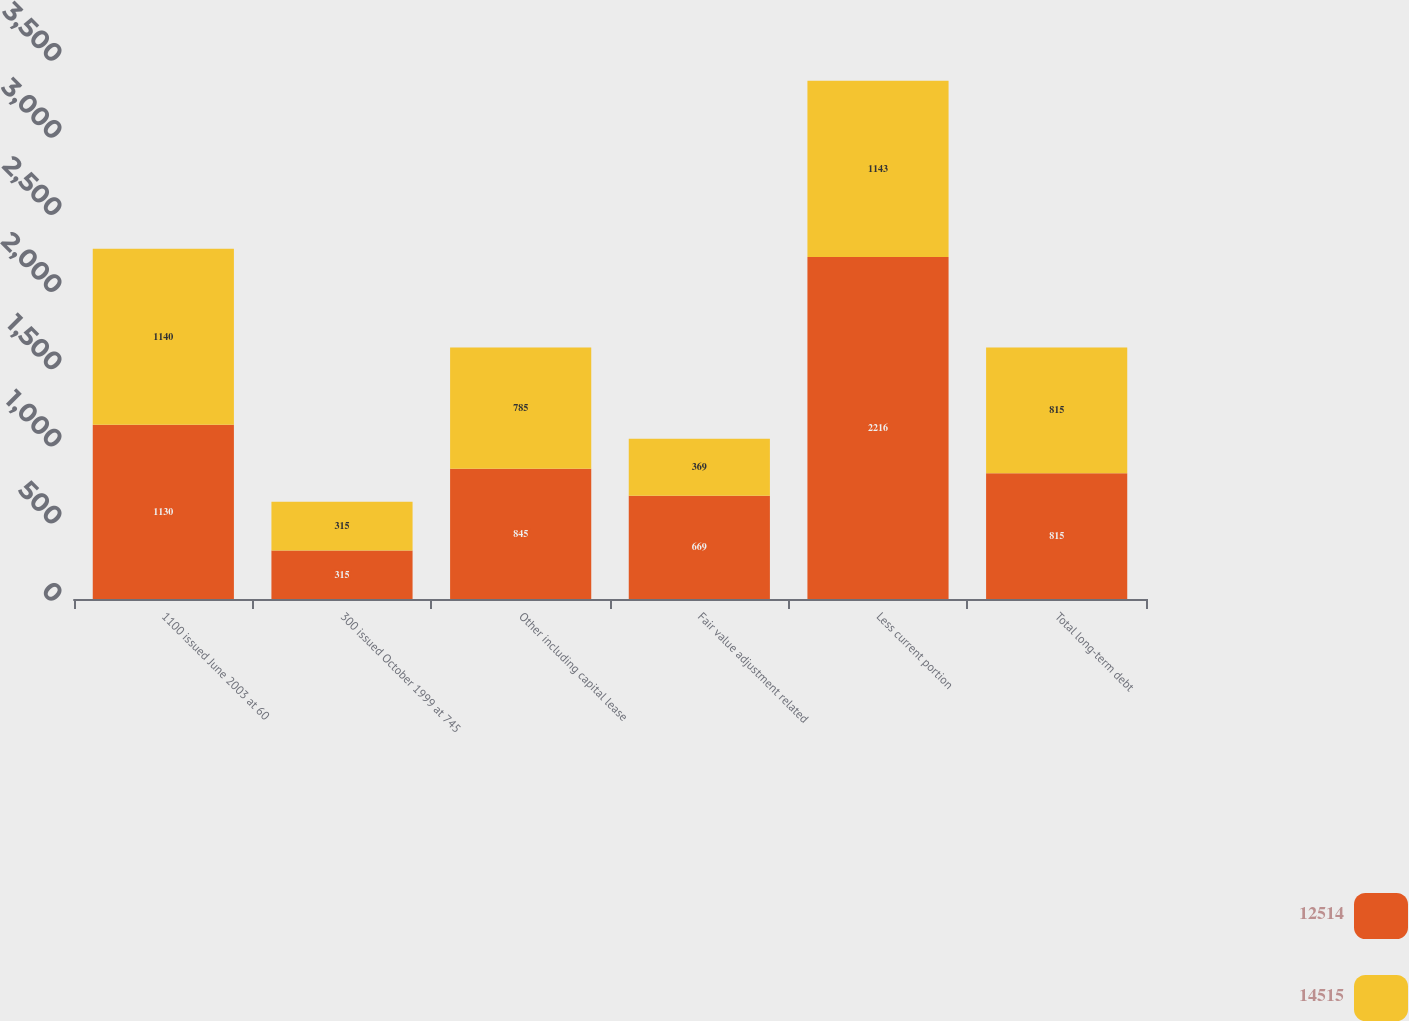Convert chart. <chart><loc_0><loc_0><loc_500><loc_500><stacked_bar_chart><ecel><fcel>1100 issued June 2003 at 60<fcel>300 issued October 1999 at 745<fcel>Other including capital lease<fcel>Fair value adjustment related<fcel>Less current portion<fcel>Total long-term debt<nl><fcel>12514<fcel>1130<fcel>315<fcel>845<fcel>669<fcel>2216<fcel>815<nl><fcel>14515<fcel>1140<fcel>315<fcel>785<fcel>369<fcel>1143<fcel>815<nl></chart> 